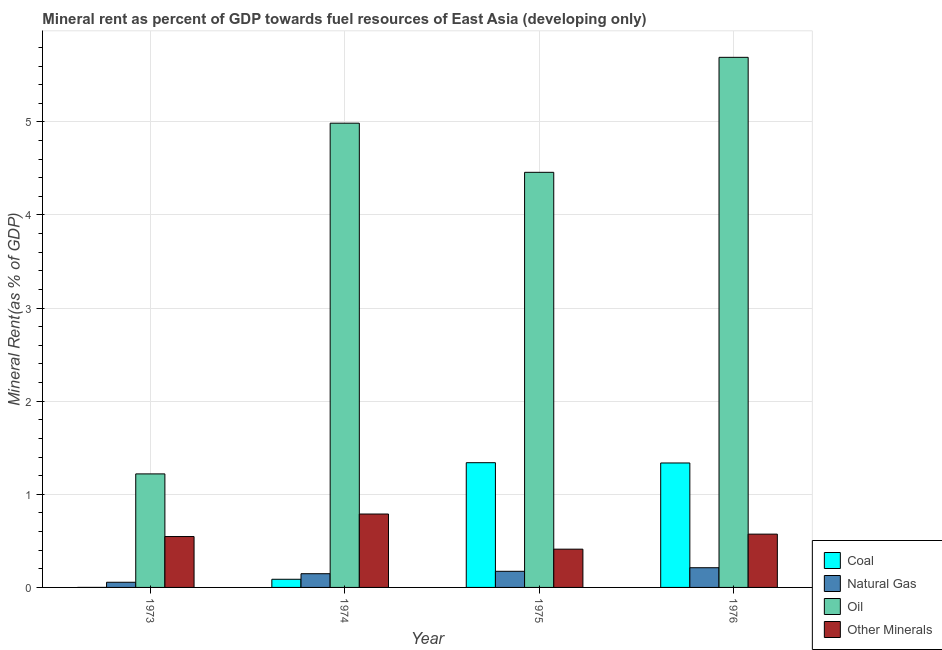Are the number of bars per tick equal to the number of legend labels?
Your response must be concise. Yes. How many bars are there on the 2nd tick from the right?
Give a very brief answer. 4. What is the label of the 2nd group of bars from the left?
Provide a succinct answer. 1974. What is the natural gas rent in 1976?
Your response must be concise. 0.21. Across all years, what is the maximum oil rent?
Your answer should be very brief. 5.69. Across all years, what is the minimum oil rent?
Make the answer very short. 1.22. In which year was the oil rent maximum?
Your answer should be compact. 1976. In which year was the coal rent minimum?
Give a very brief answer. 1973. What is the total oil rent in the graph?
Your response must be concise. 16.36. What is the difference between the  rent of other minerals in 1973 and that in 1974?
Offer a very short reply. -0.24. What is the difference between the  rent of other minerals in 1973 and the oil rent in 1975?
Give a very brief answer. 0.14. What is the average  rent of other minerals per year?
Make the answer very short. 0.58. What is the ratio of the oil rent in 1973 to that in 1976?
Make the answer very short. 0.21. Is the coal rent in 1974 less than that in 1975?
Your answer should be very brief. Yes. What is the difference between the highest and the second highest oil rent?
Ensure brevity in your answer.  0.71. What is the difference between the highest and the lowest  rent of other minerals?
Your response must be concise. 0.38. Is the sum of the coal rent in 1973 and 1974 greater than the maximum  rent of other minerals across all years?
Your answer should be compact. No. Is it the case that in every year, the sum of the oil rent and  rent of other minerals is greater than the sum of natural gas rent and coal rent?
Make the answer very short. No. What does the 1st bar from the left in 1976 represents?
Offer a terse response. Coal. What does the 1st bar from the right in 1973 represents?
Offer a very short reply. Other Minerals. Are all the bars in the graph horizontal?
Offer a terse response. No. What is the difference between two consecutive major ticks on the Y-axis?
Give a very brief answer. 1. Where does the legend appear in the graph?
Offer a terse response. Bottom right. What is the title of the graph?
Ensure brevity in your answer.  Mineral rent as percent of GDP towards fuel resources of East Asia (developing only). What is the label or title of the Y-axis?
Give a very brief answer. Mineral Rent(as % of GDP). What is the Mineral Rent(as % of GDP) of Coal in 1973?
Make the answer very short. 0. What is the Mineral Rent(as % of GDP) of Natural Gas in 1973?
Keep it short and to the point. 0.06. What is the Mineral Rent(as % of GDP) in Oil in 1973?
Your answer should be very brief. 1.22. What is the Mineral Rent(as % of GDP) in Other Minerals in 1973?
Offer a very short reply. 0.55. What is the Mineral Rent(as % of GDP) of Coal in 1974?
Your answer should be very brief. 0.09. What is the Mineral Rent(as % of GDP) in Natural Gas in 1974?
Ensure brevity in your answer.  0.15. What is the Mineral Rent(as % of GDP) in Oil in 1974?
Your answer should be very brief. 4.99. What is the Mineral Rent(as % of GDP) in Other Minerals in 1974?
Make the answer very short. 0.79. What is the Mineral Rent(as % of GDP) of Coal in 1975?
Offer a very short reply. 1.34. What is the Mineral Rent(as % of GDP) of Natural Gas in 1975?
Your answer should be compact. 0.17. What is the Mineral Rent(as % of GDP) of Oil in 1975?
Your answer should be compact. 4.46. What is the Mineral Rent(as % of GDP) in Other Minerals in 1975?
Provide a succinct answer. 0.41. What is the Mineral Rent(as % of GDP) of Coal in 1976?
Keep it short and to the point. 1.34. What is the Mineral Rent(as % of GDP) in Natural Gas in 1976?
Offer a very short reply. 0.21. What is the Mineral Rent(as % of GDP) in Oil in 1976?
Make the answer very short. 5.69. What is the Mineral Rent(as % of GDP) of Other Minerals in 1976?
Ensure brevity in your answer.  0.57. Across all years, what is the maximum Mineral Rent(as % of GDP) of Coal?
Make the answer very short. 1.34. Across all years, what is the maximum Mineral Rent(as % of GDP) of Natural Gas?
Ensure brevity in your answer.  0.21. Across all years, what is the maximum Mineral Rent(as % of GDP) of Oil?
Give a very brief answer. 5.69. Across all years, what is the maximum Mineral Rent(as % of GDP) of Other Minerals?
Keep it short and to the point. 0.79. Across all years, what is the minimum Mineral Rent(as % of GDP) in Coal?
Ensure brevity in your answer.  0. Across all years, what is the minimum Mineral Rent(as % of GDP) of Natural Gas?
Provide a succinct answer. 0.06. Across all years, what is the minimum Mineral Rent(as % of GDP) in Oil?
Make the answer very short. 1.22. Across all years, what is the minimum Mineral Rent(as % of GDP) in Other Minerals?
Your answer should be compact. 0.41. What is the total Mineral Rent(as % of GDP) in Coal in the graph?
Make the answer very short. 2.76. What is the total Mineral Rent(as % of GDP) in Natural Gas in the graph?
Make the answer very short. 0.59. What is the total Mineral Rent(as % of GDP) in Oil in the graph?
Your response must be concise. 16.36. What is the total Mineral Rent(as % of GDP) in Other Minerals in the graph?
Your answer should be very brief. 2.32. What is the difference between the Mineral Rent(as % of GDP) in Coal in 1973 and that in 1974?
Provide a succinct answer. -0.09. What is the difference between the Mineral Rent(as % of GDP) in Natural Gas in 1973 and that in 1974?
Provide a short and direct response. -0.09. What is the difference between the Mineral Rent(as % of GDP) of Oil in 1973 and that in 1974?
Provide a succinct answer. -3.77. What is the difference between the Mineral Rent(as % of GDP) of Other Minerals in 1973 and that in 1974?
Your response must be concise. -0.24. What is the difference between the Mineral Rent(as % of GDP) of Coal in 1973 and that in 1975?
Keep it short and to the point. -1.34. What is the difference between the Mineral Rent(as % of GDP) of Natural Gas in 1973 and that in 1975?
Give a very brief answer. -0.12. What is the difference between the Mineral Rent(as % of GDP) of Oil in 1973 and that in 1975?
Provide a succinct answer. -3.24. What is the difference between the Mineral Rent(as % of GDP) of Other Minerals in 1973 and that in 1975?
Offer a very short reply. 0.14. What is the difference between the Mineral Rent(as % of GDP) of Coal in 1973 and that in 1976?
Offer a terse response. -1.34. What is the difference between the Mineral Rent(as % of GDP) of Natural Gas in 1973 and that in 1976?
Your answer should be very brief. -0.16. What is the difference between the Mineral Rent(as % of GDP) of Oil in 1973 and that in 1976?
Offer a very short reply. -4.47. What is the difference between the Mineral Rent(as % of GDP) of Other Minerals in 1973 and that in 1976?
Your response must be concise. -0.03. What is the difference between the Mineral Rent(as % of GDP) in Coal in 1974 and that in 1975?
Your response must be concise. -1.25. What is the difference between the Mineral Rent(as % of GDP) in Natural Gas in 1974 and that in 1975?
Ensure brevity in your answer.  -0.03. What is the difference between the Mineral Rent(as % of GDP) in Oil in 1974 and that in 1975?
Make the answer very short. 0.53. What is the difference between the Mineral Rent(as % of GDP) in Other Minerals in 1974 and that in 1975?
Make the answer very short. 0.38. What is the difference between the Mineral Rent(as % of GDP) in Coal in 1974 and that in 1976?
Your answer should be very brief. -1.25. What is the difference between the Mineral Rent(as % of GDP) in Natural Gas in 1974 and that in 1976?
Ensure brevity in your answer.  -0.06. What is the difference between the Mineral Rent(as % of GDP) in Oil in 1974 and that in 1976?
Your answer should be compact. -0.71. What is the difference between the Mineral Rent(as % of GDP) of Other Minerals in 1974 and that in 1976?
Make the answer very short. 0.22. What is the difference between the Mineral Rent(as % of GDP) in Coal in 1975 and that in 1976?
Give a very brief answer. 0. What is the difference between the Mineral Rent(as % of GDP) in Natural Gas in 1975 and that in 1976?
Ensure brevity in your answer.  -0.04. What is the difference between the Mineral Rent(as % of GDP) in Oil in 1975 and that in 1976?
Offer a terse response. -1.23. What is the difference between the Mineral Rent(as % of GDP) in Other Minerals in 1975 and that in 1976?
Offer a terse response. -0.16. What is the difference between the Mineral Rent(as % of GDP) in Coal in 1973 and the Mineral Rent(as % of GDP) in Natural Gas in 1974?
Make the answer very short. -0.15. What is the difference between the Mineral Rent(as % of GDP) in Coal in 1973 and the Mineral Rent(as % of GDP) in Oil in 1974?
Your answer should be compact. -4.99. What is the difference between the Mineral Rent(as % of GDP) in Coal in 1973 and the Mineral Rent(as % of GDP) in Other Minerals in 1974?
Provide a short and direct response. -0.79. What is the difference between the Mineral Rent(as % of GDP) in Natural Gas in 1973 and the Mineral Rent(as % of GDP) in Oil in 1974?
Provide a succinct answer. -4.93. What is the difference between the Mineral Rent(as % of GDP) in Natural Gas in 1973 and the Mineral Rent(as % of GDP) in Other Minerals in 1974?
Your answer should be compact. -0.73. What is the difference between the Mineral Rent(as % of GDP) of Oil in 1973 and the Mineral Rent(as % of GDP) of Other Minerals in 1974?
Give a very brief answer. 0.43. What is the difference between the Mineral Rent(as % of GDP) in Coal in 1973 and the Mineral Rent(as % of GDP) in Natural Gas in 1975?
Offer a terse response. -0.17. What is the difference between the Mineral Rent(as % of GDP) of Coal in 1973 and the Mineral Rent(as % of GDP) of Oil in 1975?
Your answer should be compact. -4.46. What is the difference between the Mineral Rent(as % of GDP) in Coal in 1973 and the Mineral Rent(as % of GDP) in Other Minerals in 1975?
Provide a succinct answer. -0.41. What is the difference between the Mineral Rent(as % of GDP) in Natural Gas in 1973 and the Mineral Rent(as % of GDP) in Oil in 1975?
Give a very brief answer. -4.4. What is the difference between the Mineral Rent(as % of GDP) of Natural Gas in 1973 and the Mineral Rent(as % of GDP) of Other Minerals in 1975?
Provide a short and direct response. -0.36. What is the difference between the Mineral Rent(as % of GDP) in Oil in 1973 and the Mineral Rent(as % of GDP) in Other Minerals in 1975?
Keep it short and to the point. 0.81. What is the difference between the Mineral Rent(as % of GDP) of Coal in 1973 and the Mineral Rent(as % of GDP) of Natural Gas in 1976?
Your response must be concise. -0.21. What is the difference between the Mineral Rent(as % of GDP) in Coal in 1973 and the Mineral Rent(as % of GDP) in Oil in 1976?
Offer a terse response. -5.69. What is the difference between the Mineral Rent(as % of GDP) in Coal in 1973 and the Mineral Rent(as % of GDP) in Other Minerals in 1976?
Ensure brevity in your answer.  -0.57. What is the difference between the Mineral Rent(as % of GDP) of Natural Gas in 1973 and the Mineral Rent(as % of GDP) of Oil in 1976?
Your response must be concise. -5.64. What is the difference between the Mineral Rent(as % of GDP) of Natural Gas in 1973 and the Mineral Rent(as % of GDP) of Other Minerals in 1976?
Offer a terse response. -0.52. What is the difference between the Mineral Rent(as % of GDP) of Oil in 1973 and the Mineral Rent(as % of GDP) of Other Minerals in 1976?
Your response must be concise. 0.65. What is the difference between the Mineral Rent(as % of GDP) of Coal in 1974 and the Mineral Rent(as % of GDP) of Natural Gas in 1975?
Keep it short and to the point. -0.09. What is the difference between the Mineral Rent(as % of GDP) in Coal in 1974 and the Mineral Rent(as % of GDP) in Oil in 1975?
Keep it short and to the point. -4.37. What is the difference between the Mineral Rent(as % of GDP) of Coal in 1974 and the Mineral Rent(as % of GDP) of Other Minerals in 1975?
Your answer should be very brief. -0.32. What is the difference between the Mineral Rent(as % of GDP) of Natural Gas in 1974 and the Mineral Rent(as % of GDP) of Oil in 1975?
Provide a succinct answer. -4.31. What is the difference between the Mineral Rent(as % of GDP) of Natural Gas in 1974 and the Mineral Rent(as % of GDP) of Other Minerals in 1975?
Ensure brevity in your answer.  -0.26. What is the difference between the Mineral Rent(as % of GDP) in Oil in 1974 and the Mineral Rent(as % of GDP) in Other Minerals in 1975?
Provide a succinct answer. 4.58. What is the difference between the Mineral Rent(as % of GDP) of Coal in 1974 and the Mineral Rent(as % of GDP) of Natural Gas in 1976?
Offer a terse response. -0.12. What is the difference between the Mineral Rent(as % of GDP) in Coal in 1974 and the Mineral Rent(as % of GDP) in Oil in 1976?
Your response must be concise. -5.61. What is the difference between the Mineral Rent(as % of GDP) of Coal in 1974 and the Mineral Rent(as % of GDP) of Other Minerals in 1976?
Provide a short and direct response. -0.48. What is the difference between the Mineral Rent(as % of GDP) of Natural Gas in 1974 and the Mineral Rent(as % of GDP) of Oil in 1976?
Provide a succinct answer. -5.55. What is the difference between the Mineral Rent(as % of GDP) of Natural Gas in 1974 and the Mineral Rent(as % of GDP) of Other Minerals in 1976?
Ensure brevity in your answer.  -0.43. What is the difference between the Mineral Rent(as % of GDP) in Oil in 1974 and the Mineral Rent(as % of GDP) in Other Minerals in 1976?
Offer a terse response. 4.41. What is the difference between the Mineral Rent(as % of GDP) of Coal in 1975 and the Mineral Rent(as % of GDP) of Natural Gas in 1976?
Your answer should be compact. 1.13. What is the difference between the Mineral Rent(as % of GDP) of Coal in 1975 and the Mineral Rent(as % of GDP) of Oil in 1976?
Ensure brevity in your answer.  -4.35. What is the difference between the Mineral Rent(as % of GDP) in Coal in 1975 and the Mineral Rent(as % of GDP) in Other Minerals in 1976?
Provide a short and direct response. 0.77. What is the difference between the Mineral Rent(as % of GDP) of Natural Gas in 1975 and the Mineral Rent(as % of GDP) of Oil in 1976?
Keep it short and to the point. -5.52. What is the difference between the Mineral Rent(as % of GDP) of Natural Gas in 1975 and the Mineral Rent(as % of GDP) of Other Minerals in 1976?
Provide a short and direct response. -0.4. What is the difference between the Mineral Rent(as % of GDP) of Oil in 1975 and the Mineral Rent(as % of GDP) of Other Minerals in 1976?
Make the answer very short. 3.89. What is the average Mineral Rent(as % of GDP) of Coal per year?
Keep it short and to the point. 0.69. What is the average Mineral Rent(as % of GDP) in Natural Gas per year?
Make the answer very short. 0.15. What is the average Mineral Rent(as % of GDP) in Oil per year?
Make the answer very short. 4.09. What is the average Mineral Rent(as % of GDP) of Other Minerals per year?
Ensure brevity in your answer.  0.58. In the year 1973, what is the difference between the Mineral Rent(as % of GDP) of Coal and Mineral Rent(as % of GDP) of Natural Gas?
Offer a very short reply. -0.06. In the year 1973, what is the difference between the Mineral Rent(as % of GDP) of Coal and Mineral Rent(as % of GDP) of Oil?
Provide a succinct answer. -1.22. In the year 1973, what is the difference between the Mineral Rent(as % of GDP) in Coal and Mineral Rent(as % of GDP) in Other Minerals?
Offer a very short reply. -0.55. In the year 1973, what is the difference between the Mineral Rent(as % of GDP) in Natural Gas and Mineral Rent(as % of GDP) in Oil?
Your answer should be compact. -1.16. In the year 1973, what is the difference between the Mineral Rent(as % of GDP) in Natural Gas and Mineral Rent(as % of GDP) in Other Minerals?
Give a very brief answer. -0.49. In the year 1973, what is the difference between the Mineral Rent(as % of GDP) of Oil and Mineral Rent(as % of GDP) of Other Minerals?
Give a very brief answer. 0.67. In the year 1974, what is the difference between the Mineral Rent(as % of GDP) in Coal and Mineral Rent(as % of GDP) in Natural Gas?
Offer a very short reply. -0.06. In the year 1974, what is the difference between the Mineral Rent(as % of GDP) of Coal and Mineral Rent(as % of GDP) of Oil?
Your answer should be compact. -4.9. In the year 1974, what is the difference between the Mineral Rent(as % of GDP) of Coal and Mineral Rent(as % of GDP) of Other Minerals?
Offer a terse response. -0.7. In the year 1974, what is the difference between the Mineral Rent(as % of GDP) of Natural Gas and Mineral Rent(as % of GDP) of Oil?
Offer a very short reply. -4.84. In the year 1974, what is the difference between the Mineral Rent(as % of GDP) in Natural Gas and Mineral Rent(as % of GDP) in Other Minerals?
Your answer should be compact. -0.64. In the year 1974, what is the difference between the Mineral Rent(as % of GDP) of Oil and Mineral Rent(as % of GDP) of Other Minerals?
Offer a terse response. 4.2. In the year 1975, what is the difference between the Mineral Rent(as % of GDP) in Coal and Mineral Rent(as % of GDP) in Natural Gas?
Offer a terse response. 1.17. In the year 1975, what is the difference between the Mineral Rent(as % of GDP) in Coal and Mineral Rent(as % of GDP) in Oil?
Your response must be concise. -3.12. In the year 1975, what is the difference between the Mineral Rent(as % of GDP) of Coal and Mineral Rent(as % of GDP) of Other Minerals?
Provide a succinct answer. 0.93. In the year 1975, what is the difference between the Mineral Rent(as % of GDP) of Natural Gas and Mineral Rent(as % of GDP) of Oil?
Make the answer very short. -4.29. In the year 1975, what is the difference between the Mineral Rent(as % of GDP) of Natural Gas and Mineral Rent(as % of GDP) of Other Minerals?
Keep it short and to the point. -0.24. In the year 1975, what is the difference between the Mineral Rent(as % of GDP) of Oil and Mineral Rent(as % of GDP) of Other Minerals?
Keep it short and to the point. 4.05. In the year 1976, what is the difference between the Mineral Rent(as % of GDP) in Coal and Mineral Rent(as % of GDP) in Natural Gas?
Your answer should be very brief. 1.12. In the year 1976, what is the difference between the Mineral Rent(as % of GDP) of Coal and Mineral Rent(as % of GDP) of Oil?
Give a very brief answer. -4.36. In the year 1976, what is the difference between the Mineral Rent(as % of GDP) in Coal and Mineral Rent(as % of GDP) in Other Minerals?
Offer a terse response. 0.76. In the year 1976, what is the difference between the Mineral Rent(as % of GDP) of Natural Gas and Mineral Rent(as % of GDP) of Oil?
Your answer should be very brief. -5.48. In the year 1976, what is the difference between the Mineral Rent(as % of GDP) in Natural Gas and Mineral Rent(as % of GDP) in Other Minerals?
Your response must be concise. -0.36. In the year 1976, what is the difference between the Mineral Rent(as % of GDP) in Oil and Mineral Rent(as % of GDP) in Other Minerals?
Ensure brevity in your answer.  5.12. What is the ratio of the Mineral Rent(as % of GDP) of Coal in 1973 to that in 1974?
Give a very brief answer. 0. What is the ratio of the Mineral Rent(as % of GDP) of Natural Gas in 1973 to that in 1974?
Offer a terse response. 0.38. What is the ratio of the Mineral Rent(as % of GDP) of Oil in 1973 to that in 1974?
Provide a short and direct response. 0.24. What is the ratio of the Mineral Rent(as % of GDP) in Other Minerals in 1973 to that in 1974?
Your answer should be very brief. 0.69. What is the ratio of the Mineral Rent(as % of GDP) of Coal in 1973 to that in 1975?
Offer a terse response. 0. What is the ratio of the Mineral Rent(as % of GDP) in Natural Gas in 1973 to that in 1975?
Your response must be concise. 0.32. What is the ratio of the Mineral Rent(as % of GDP) in Oil in 1973 to that in 1975?
Offer a very short reply. 0.27. What is the ratio of the Mineral Rent(as % of GDP) of Other Minerals in 1973 to that in 1975?
Keep it short and to the point. 1.33. What is the ratio of the Mineral Rent(as % of GDP) of Natural Gas in 1973 to that in 1976?
Ensure brevity in your answer.  0.26. What is the ratio of the Mineral Rent(as % of GDP) of Oil in 1973 to that in 1976?
Give a very brief answer. 0.21. What is the ratio of the Mineral Rent(as % of GDP) of Other Minerals in 1973 to that in 1976?
Make the answer very short. 0.95. What is the ratio of the Mineral Rent(as % of GDP) of Coal in 1974 to that in 1975?
Ensure brevity in your answer.  0.07. What is the ratio of the Mineral Rent(as % of GDP) in Natural Gas in 1974 to that in 1975?
Offer a terse response. 0.85. What is the ratio of the Mineral Rent(as % of GDP) of Oil in 1974 to that in 1975?
Offer a terse response. 1.12. What is the ratio of the Mineral Rent(as % of GDP) of Other Minerals in 1974 to that in 1975?
Give a very brief answer. 1.92. What is the ratio of the Mineral Rent(as % of GDP) in Coal in 1974 to that in 1976?
Keep it short and to the point. 0.07. What is the ratio of the Mineral Rent(as % of GDP) in Natural Gas in 1974 to that in 1976?
Keep it short and to the point. 0.7. What is the ratio of the Mineral Rent(as % of GDP) of Oil in 1974 to that in 1976?
Give a very brief answer. 0.88. What is the ratio of the Mineral Rent(as % of GDP) of Other Minerals in 1974 to that in 1976?
Your answer should be compact. 1.38. What is the ratio of the Mineral Rent(as % of GDP) of Coal in 1975 to that in 1976?
Ensure brevity in your answer.  1. What is the ratio of the Mineral Rent(as % of GDP) of Natural Gas in 1975 to that in 1976?
Make the answer very short. 0.82. What is the ratio of the Mineral Rent(as % of GDP) of Oil in 1975 to that in 1976?
Your answer should be compact. 0.78. What is the ratio of the Mineral Rent(as % of GDP) in Other Minerals in 1975 to that in 1976?
Provide a short and direct response. 0.72. What is the difference between the highest and the second highest Mineral Rent(as % of GDP) in Coal?
Your answer should be very brief. 0. What is the difference between the highest and the second highest Mineral Rent(as % of GDP) of Natural Gas?
Provide a succinct answer. 0.04. What is the difference between the highest and the second highest Mineral Rent(as % of GDP) in Oil?
Give a very brief answer. 0.71. What is the difference between the highest and the second highest Mineral Rent(as % of GDP) in Other Minerals?
Provide a short and direct response. 0.22. What is the difference between the highest and the lowest Mineral Rent(as % of GDP) in Coal?
Provide a short and direct response. 1.34. What is the difference between the highest and the lowest Mineral Rent(as % of GDP) of Natural Gas?
Keep it short and to the point. 0.16. What is the difference between the highest and the lowest Mineral Rent(as % of GDP) in Oil?
Make the answer very short. 4.47. What is the difference between the highest and the lowest Mineral Rent(as % of GDP) in Other Minerals?
Provide a short and direct response. 0.38. 